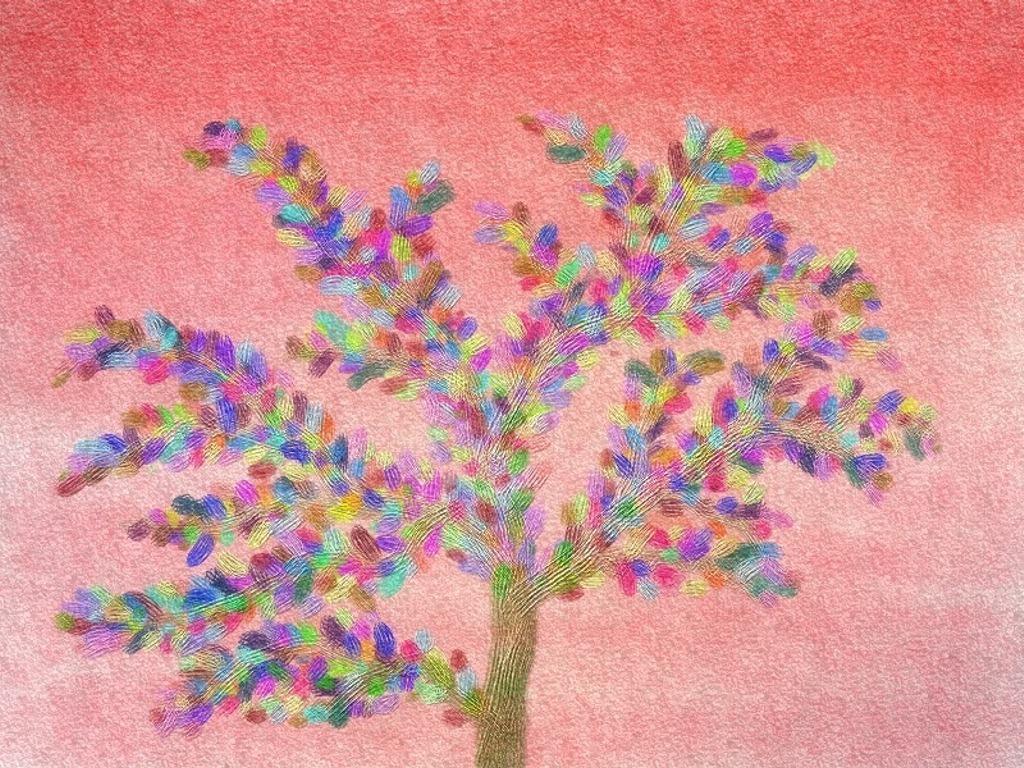In one or two sentences, can you explain what this image depicts? In the center of the image we can see a painting of a tree. 